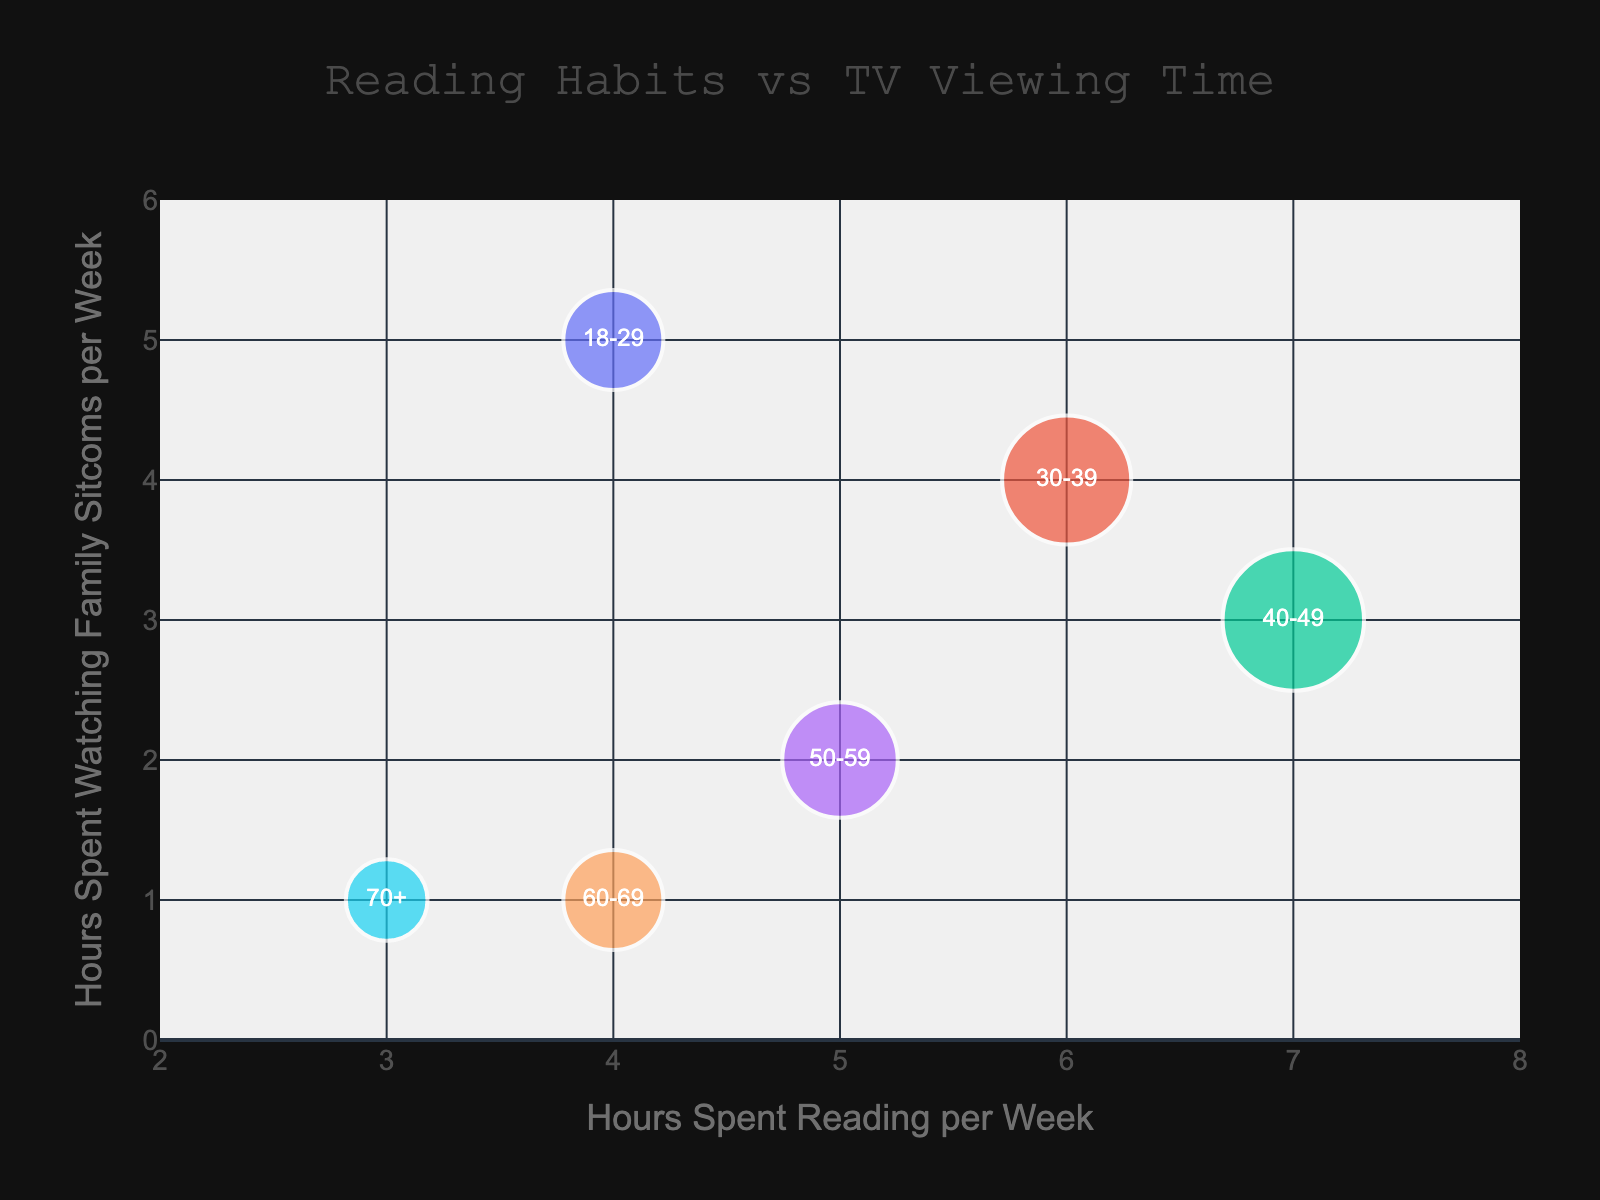What is the title of the figure? The title of the figure is the text displayed prominently at the top center of the chart. In this figure, the title is "Reading Habits vs TV Viewing Time".
Answer: Reading Habits vs TV Viewing Time How many age groups are represented in the figure? The figure shows different colored bubbles, each representing an age group. By counting the bubbles, we can see there are six different age groups.
Answer: Six Which age group spends the most hours reading per week? The X-axis represents hours spent reading per week. The bubble farthest to the right has the highest value on the X-axis, which corresponds to the 40-49 age group.
Answer: 40-49 What is the approximate bubble size for the age group 30-39? The bubbles' sizes are based on the number of bookstore visits per month. Since each visit is multiplied by 10 for the bubble size, the age group 30-39 has 5 visits, making its bubble size approximately 50, which is the maximum bubble size.
Answer: Approximately 50 Which age group spends the least hours watching family sitcoms per week? The Y-axis represents hours spent watching family sitcoms per week. The bubble farthest down has the lowest value on the Y-axis, which corresponds to the 60-69 and 70+ age groups, both at 1 hour each per week.
Answer: 60-69 and 70+ How do the hours spent reading compare between the age groups 18-29 and 70+? Look at the X-axis values for both age groups. The 18-29 age group is at 4 hours, and the 70+ age group is at 3 hours. Subtracting these gives 4 - 3 = 1.
Answer: 1 hour more for 18-29 Calculate the average hours spent reading per week across all age groups. Sum all the hours spent reading per week for each age group (4 + 6 + 7 + 5 + 4 + 3), which equals 29. Divide this by the number of age groups (6). 29 / 6 = 4.83 (approximately).
Answer: Approximately 4.83 Which age group has the highest number of bookstore visits per month? The bubble sizes are based on the number of bookstore visits per month. The largest bubble corresponds to the 40-49 age group, which has 6 visits per month.
Answer: 40-49 Compare the relationship between reading and watching family sitcoms for age groups 40-49 and 50-59. For the 40-49 age group, the hours spent reading is 7 and watching family sitcoms is 3. For the 50-59 age group, the hours spent reading is 5 and watching family sitcoms is 2. Subtracting reading hours for 40-49 from 50-59 gives 7 - 5 = 2. Subtracting watching hours gives 3 - 2 = 1. So the 40-49 group spends 2 more hours reading and 1 more hour watching family sitcoms than the 50-59 group.
Answer: 2 more hours reading, 1 more hour watching 